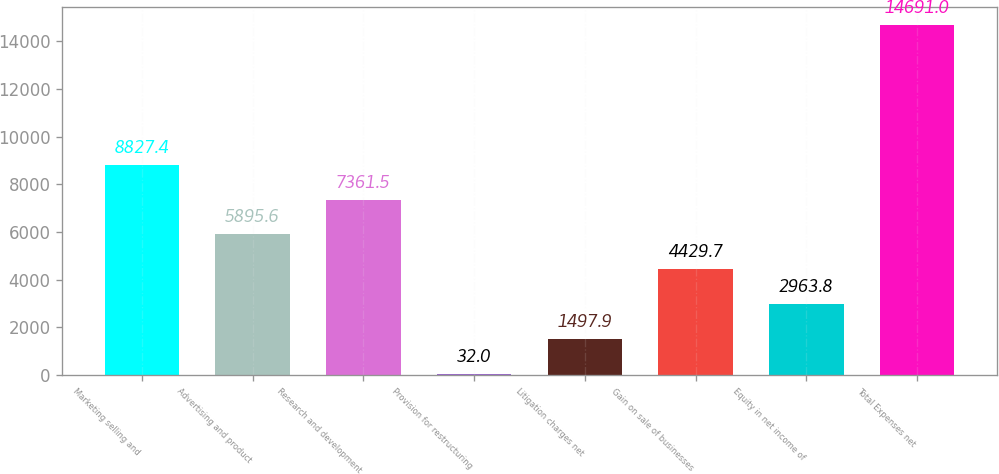Convert chart to OTSL. <chart><loc_0><loc_0><loc_500><loc_500><bar_chart><fcel>Marketing selling and<fcel>Advertising and product<fcel>Research and development<fcel>Provision for restructuring<fcel>Litigation charges net<fcel>Gain on sale of businesses<fcel>Equity in net income of<fcel>Total Expenses net<nl><fcel>8827.4<fcel>5895.6<fcel>7361.5<fcel>32<fcel>1497.9<fcel>4429.7<fcel>2963.8<fcel>14691<nl></chart> 